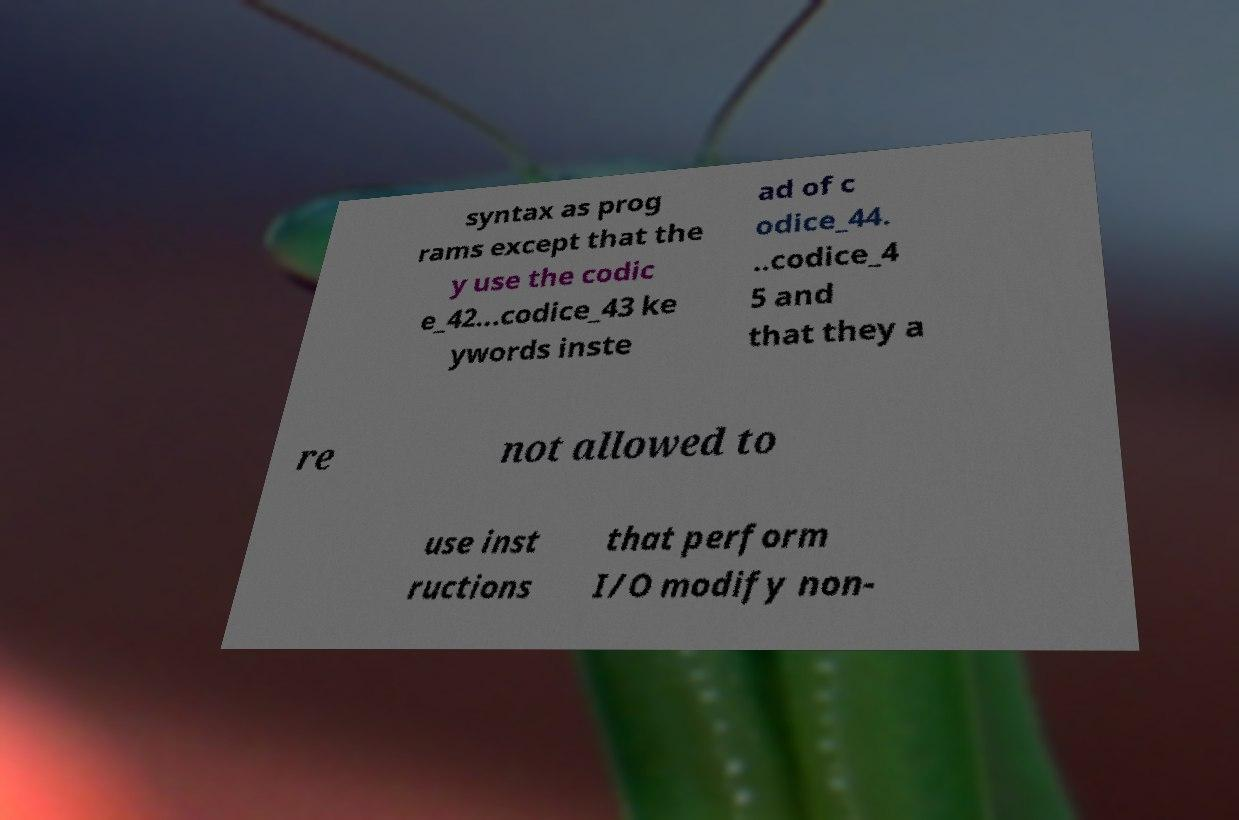Could you extract and type out the text from this image? syntax as prog rams except that the y use the codic e_42...codice_43 ke ywords inste ad of c odice_44. ..codice_4 5 and that they a re not allowed to use inst ructions that perform I/O modify non- 